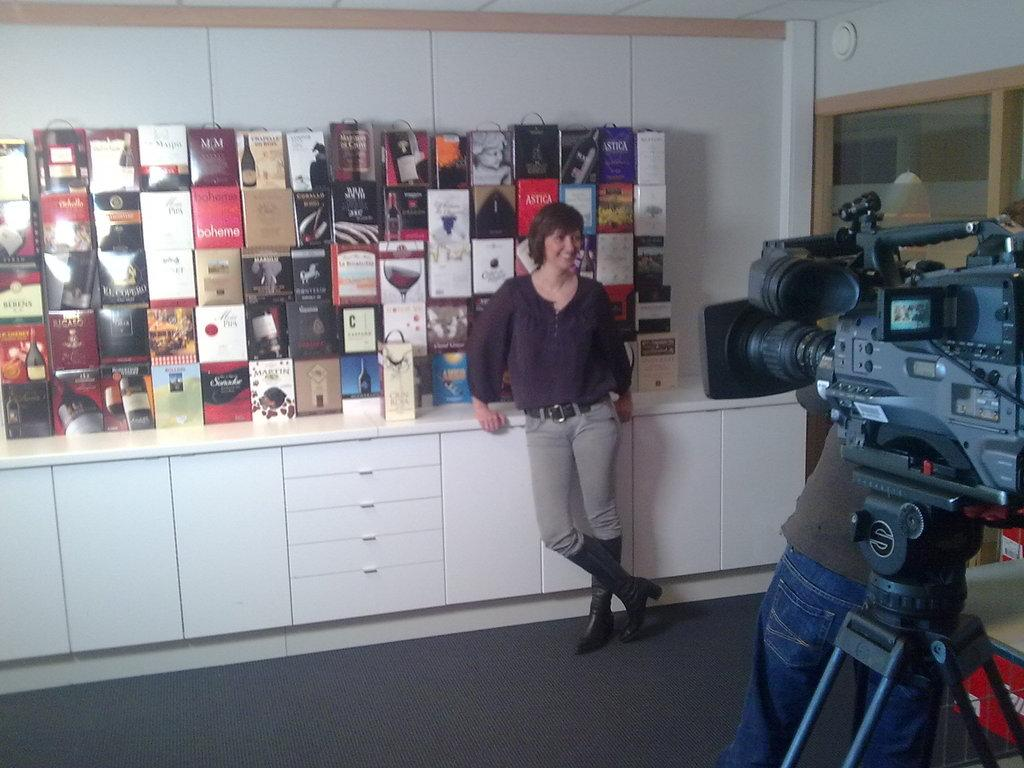Who is present in the image? There is a woman in the image. What is the woman's expression? The woman is smiling. What equipment is set up in front of the image? There is a video camera on a camera stand in front of the image. What type of furniture can be seen in the background of the image? There are wooden cupboards in the background of the image. What other objects are visible in the background of the image? There are other objects visible in the background of the image, but their specific details are not mentioned in the provided facts. What type of drink is the woman holding in the image? There is no drink visible in the image; the woman is not holding anything. What type of carriage is present in the image? There is no carriage present in the image. 